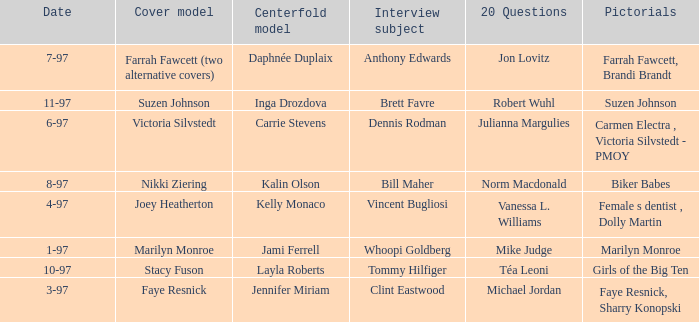What is the name of the cover model on 3-97? Faye Resnick. 